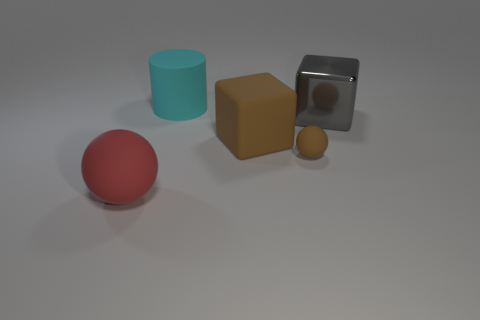Is the color of the small object the same as the matte cube?
Your answer should be very brief. Yes. What shape is the other matte thing that is the same color as the tiny object?
Give a very brief answer. Cube. What material is the large object that is both behind the matte block and to the right of the large cyan matte cylinder?
Give a very brief answer. Metal. What is the size of the matte thing that is the same color as the small matte sphere?
Offer a very short reply. Large. What number of other things are the same size as the red rubber object?
Ensure brevity in your answer.  3. What material is the brown thing in front of the big matte block?
Give a very brief answer. Rubber. Do the tiny rubber thing and the large red matte object have the same shape?
Keep it short and to the point. Yes. How many other objects are the same shape as the large red thing?
Your response must be concise. 1. What is the color of the big rubber thing in front of the small brown sphere?
Offer a very short reply. Red. Does the brown matte sphere have the same size as the cyan object?
Offer a terse response. No. 